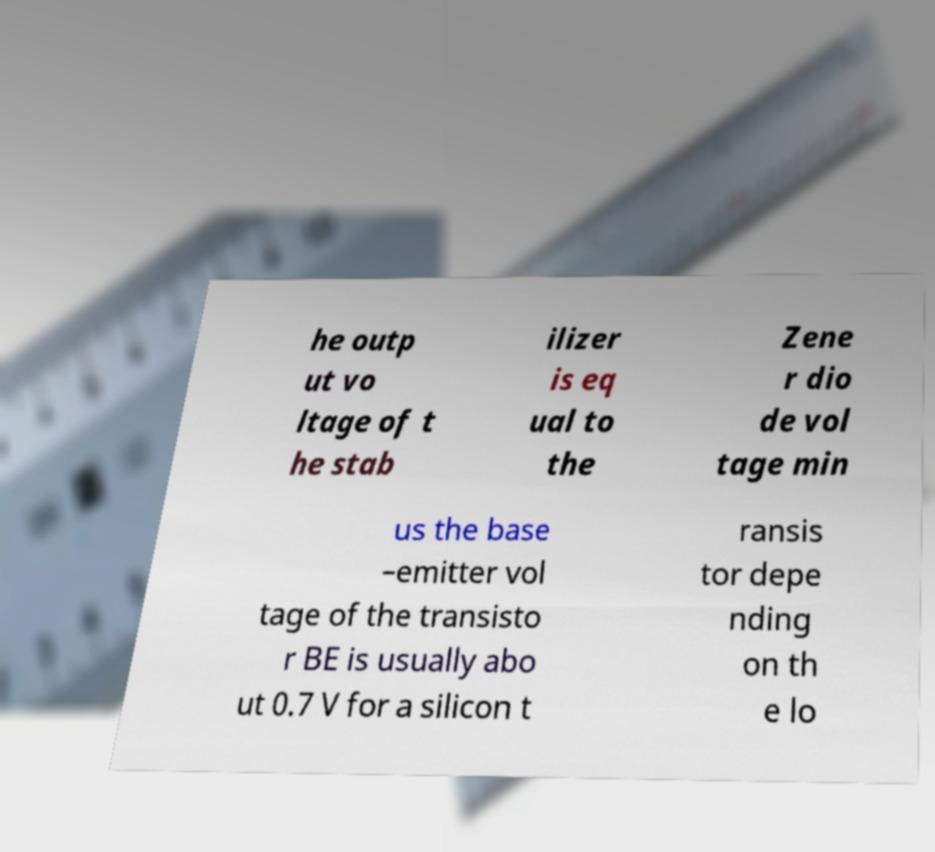Can you read and provide the text displayed in the image?This photo seems to have some interesting text. Can you extract and type it out for me? he outp ut vo ltage of t he stab ilizer is eq ual to the Zene r dio de vol tage min us the base –emitter vol tage of the transisto r BE is usually abo ut 0.7 V for a silicon t ransis tor depe nding on th e lo 